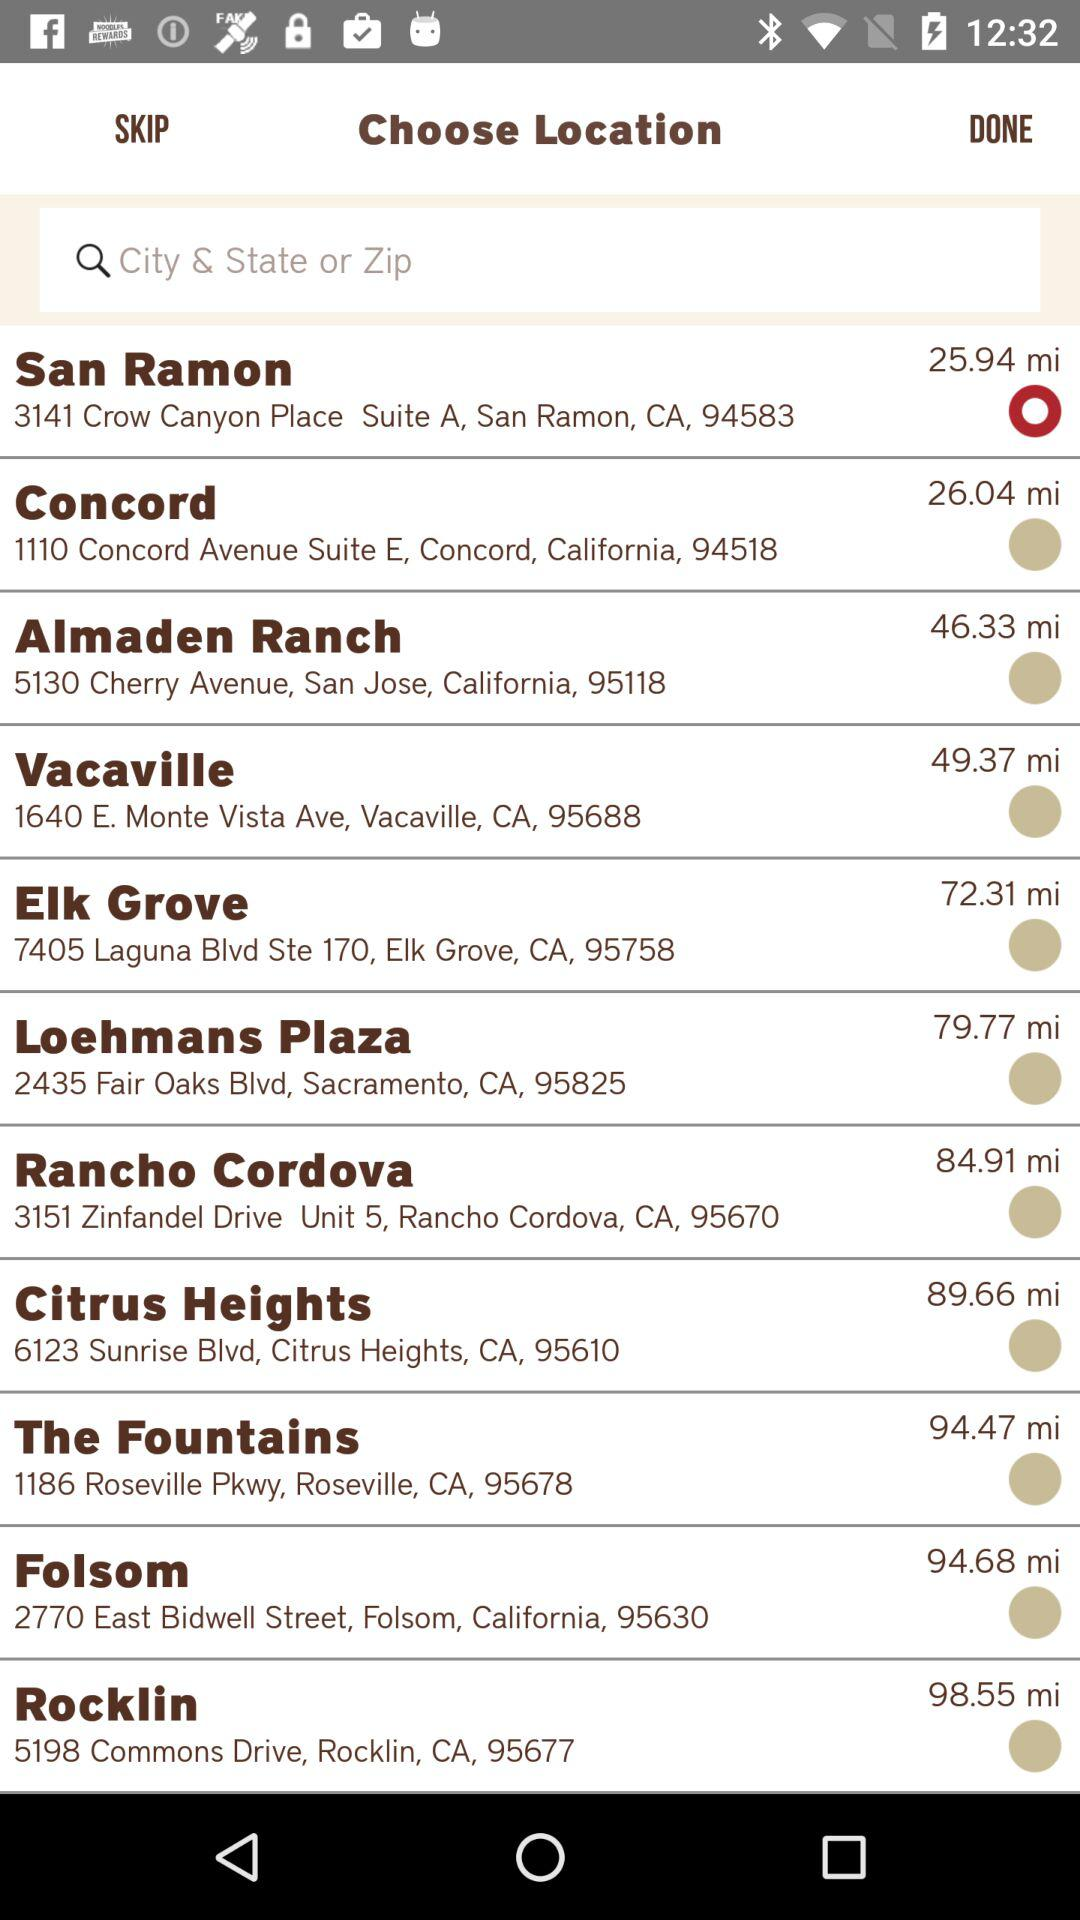What is the location of San Ramon? The location of San Ramon is 3141 Crow Canyon Place Suite A, San Ramon, CA, 94583. 